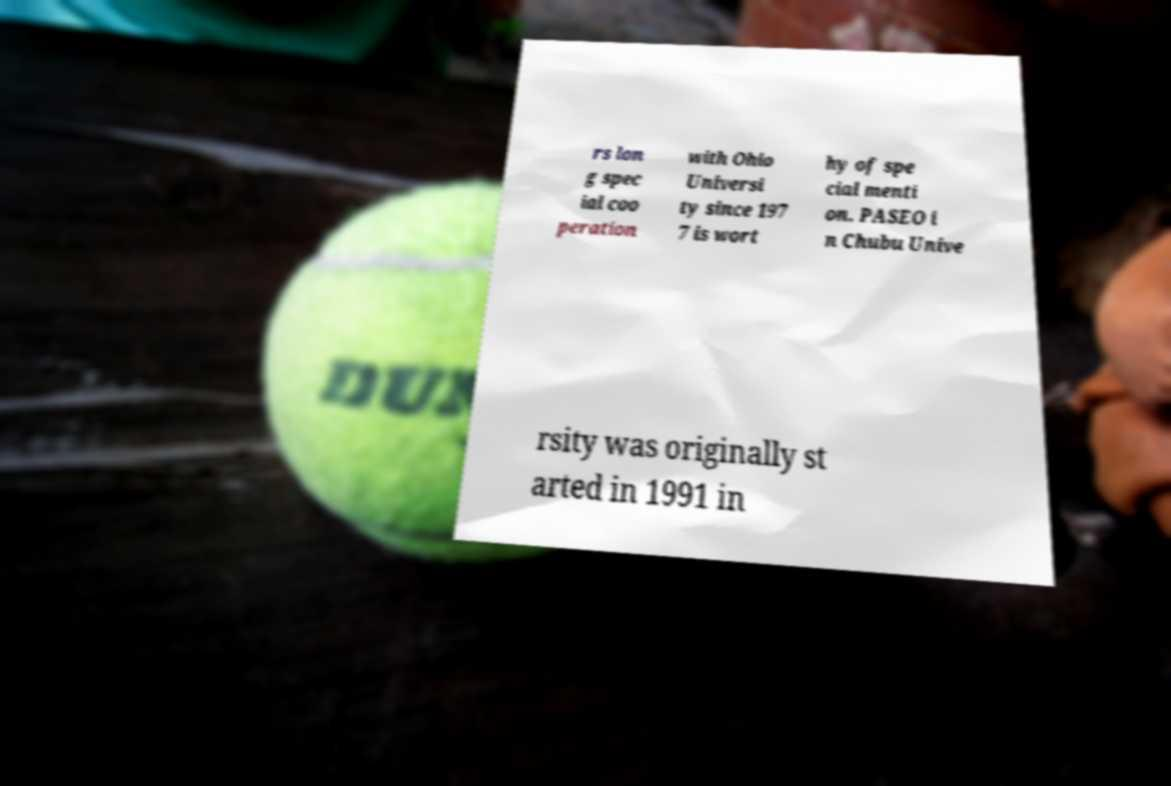What messages or text are displayed in this image? I need them in a readable, typed format. rs lon g spec ial coo peration with Ohio Universi ty since 197 7 is wort hy of spe cial menti on. PASEO i n Chubu Unive rsity was originally st arted in 1991 in 